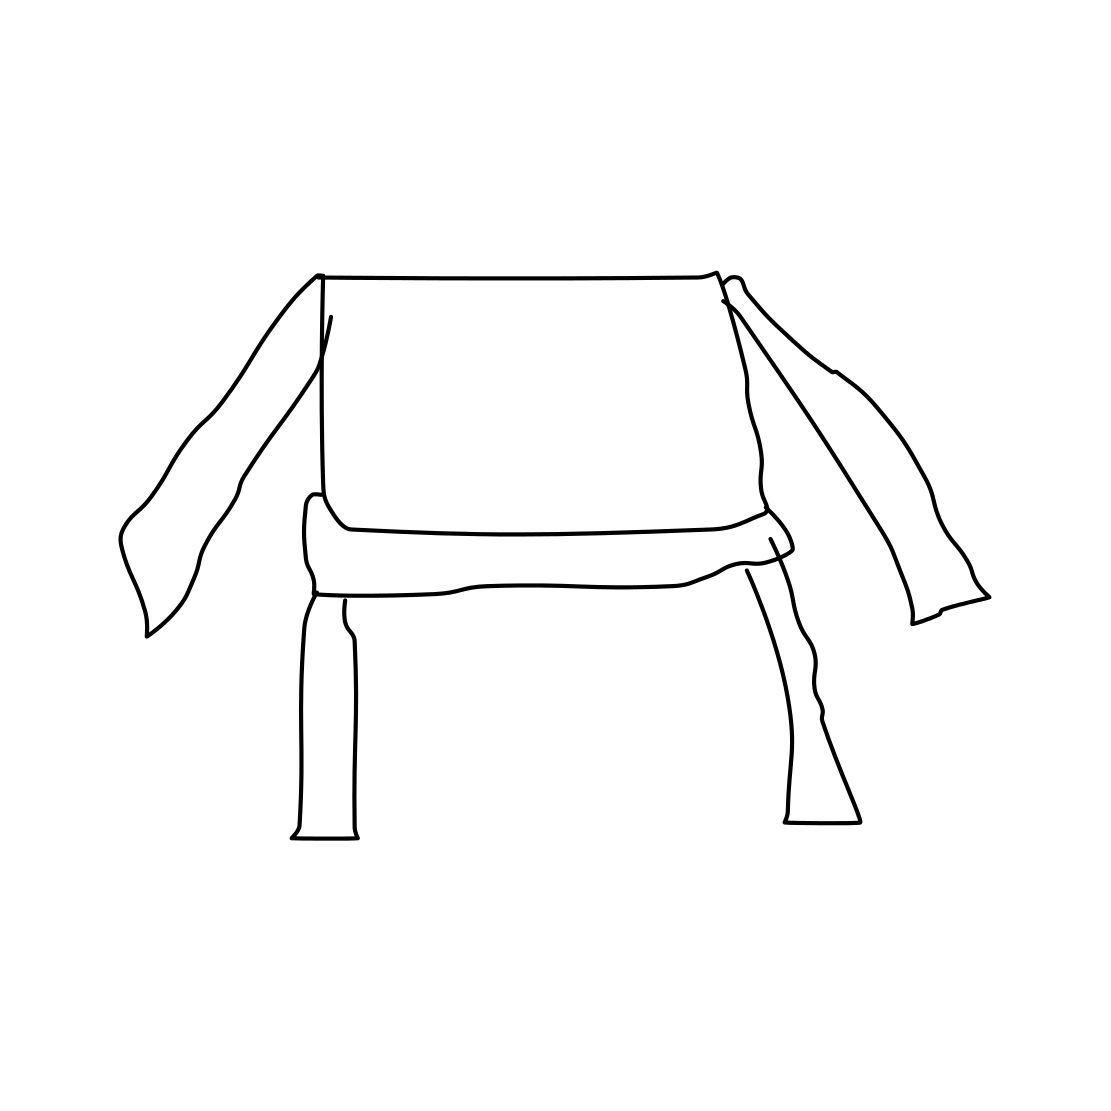Is this a wheelbarrow in the image? No 